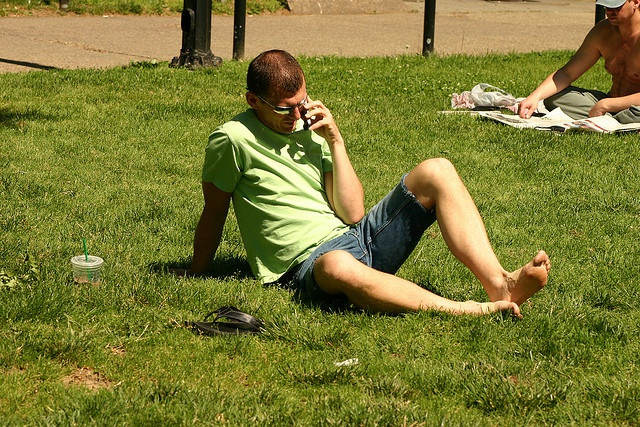Describe the objects in this image and their specific colors. I can see people in olive, black, khaki, and darkgreen tones, people in olive, maroon, black, and tan tones, cup in olive and beige tones, cell phone in olive, black, maroon, white, and gray tones, and cell phone in olive, ivory, black, tan, and gray tones in this image. 